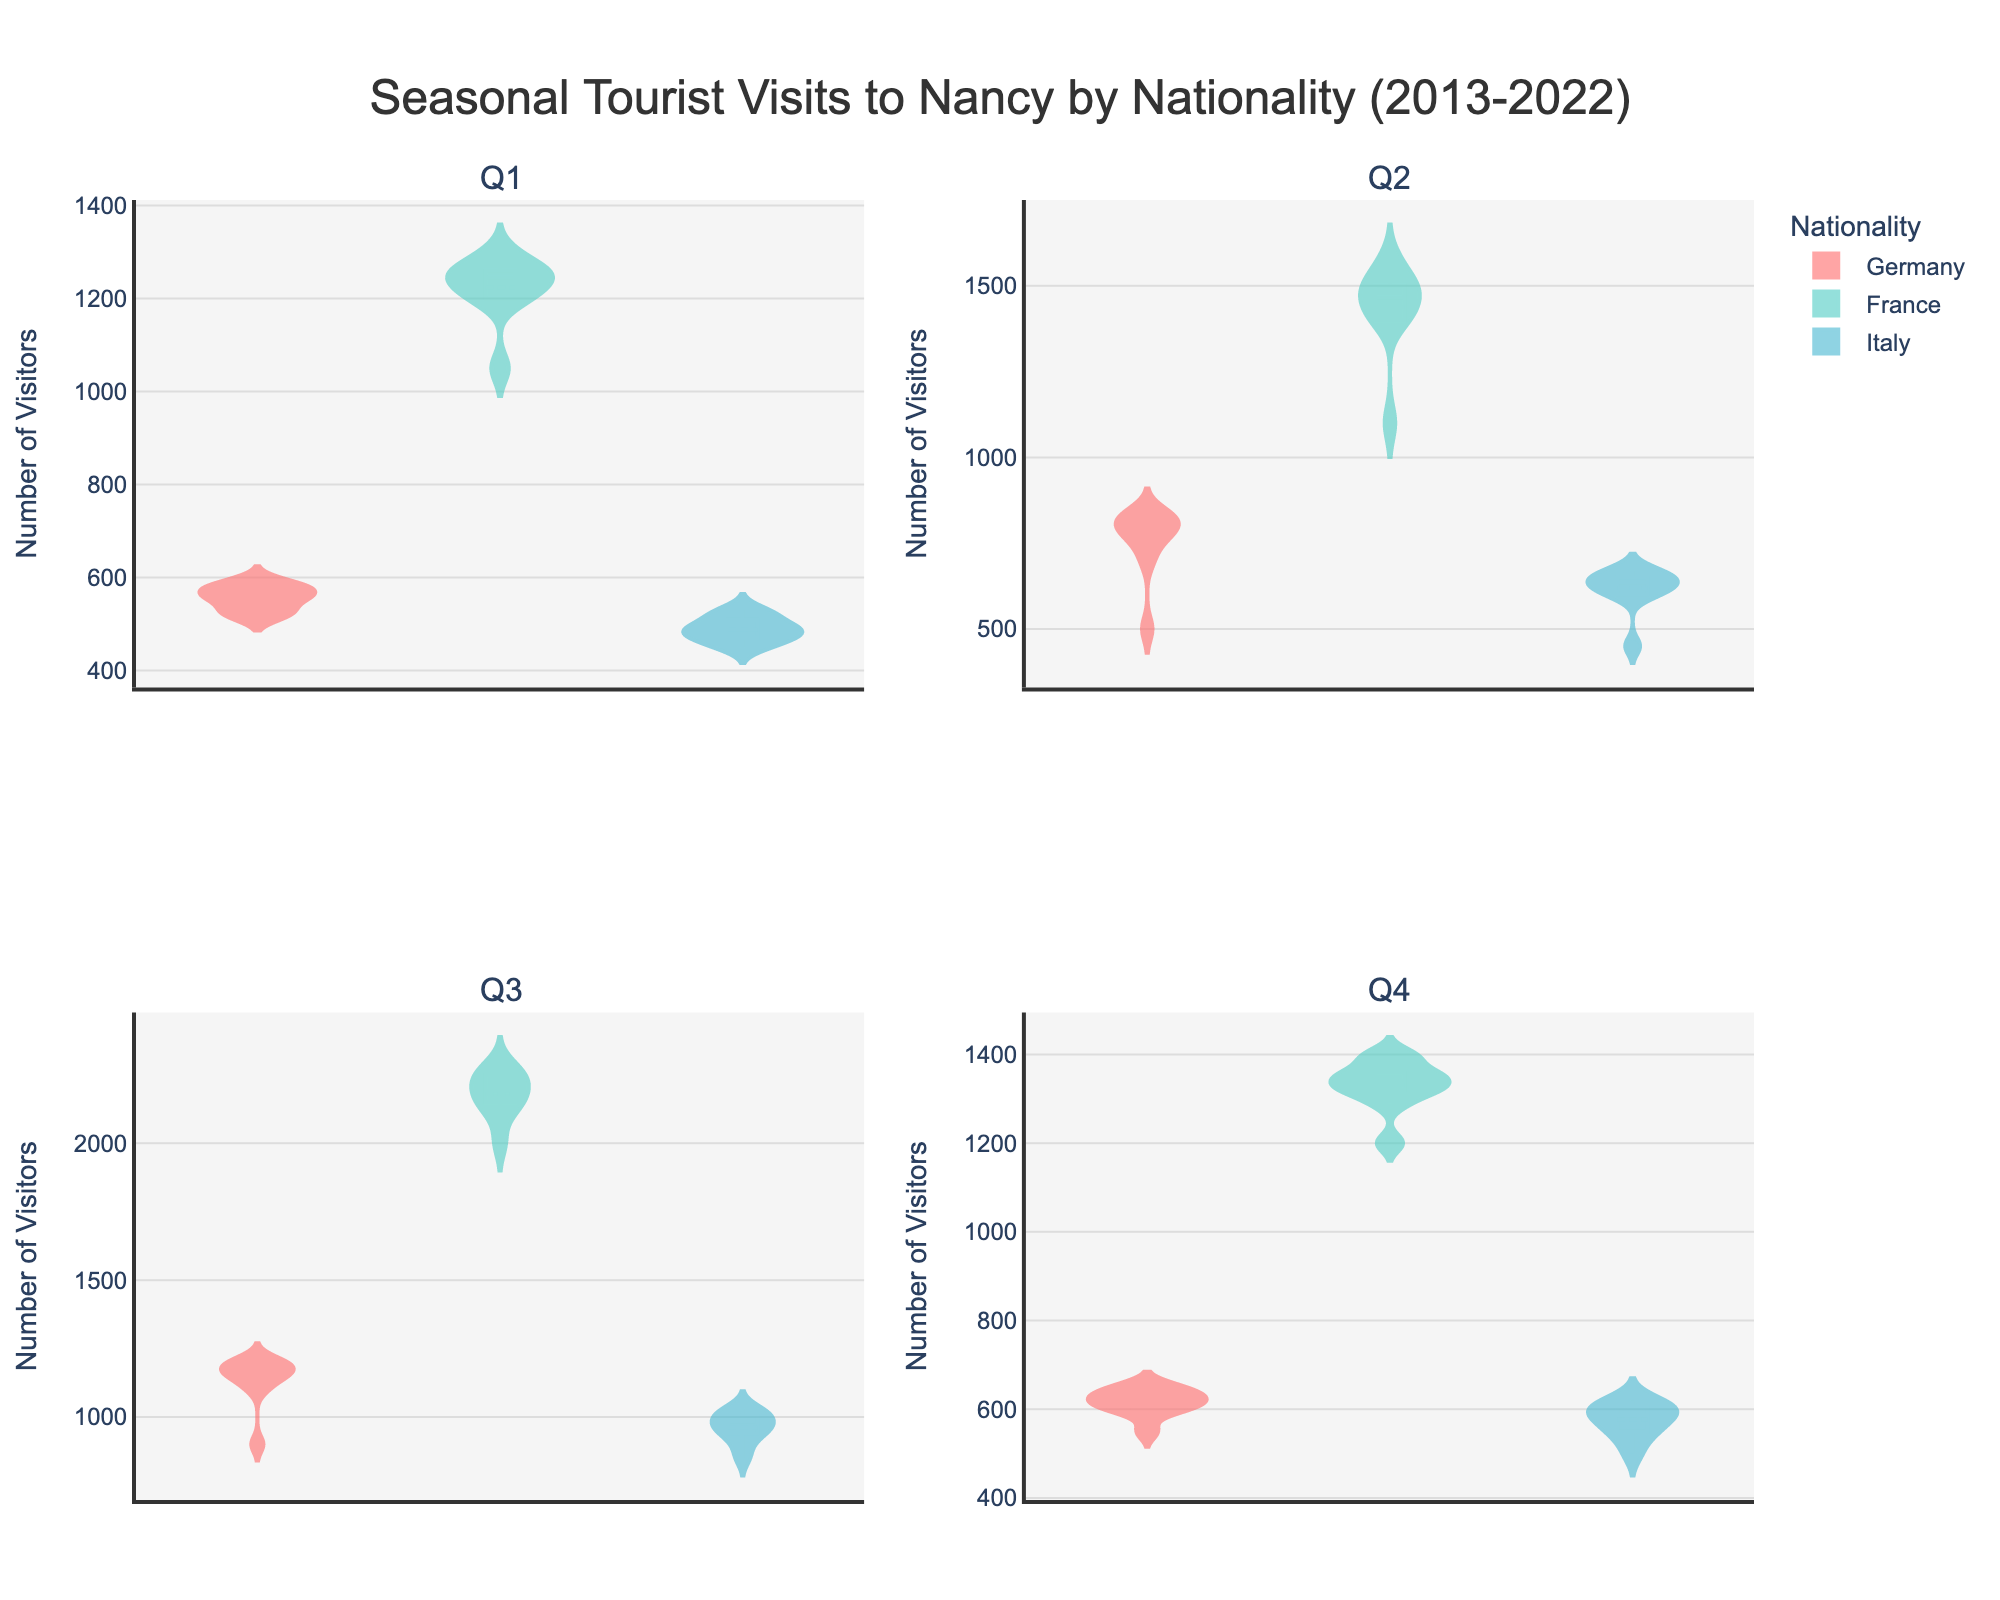What is the title of the figure? The title of the figure is prominently displayed at the top and provides an overview of the content being presented.
Answer: Seasonal Tourist Visits to Nancy by Nationality (2013-2022) How many subplots are there in the figure? There are four sections in the figure, each representing data for a different seasonal quarter. These sections are visually distinct and arranged in a 2x2 grid.
Answer: Four Which nationality tends to have the highest number of visitors in Q3? Observing the violin plots in the Q3 subplot, the plots show the distribution and mean number of visitors. The plot with the blue color, representing France, consistently has the highest values.
Answer: France What is the average number of visitors from Germany in Q1? To find the average, sum the number of visitors from Germany in Q1 for each year and then divide by the number of years (10 years). The sum is 550 + 520 + 560 + 530 + 570 + 580 + 590 + 560 + 520 + 580 = 5560. Dividing by 10 gives the average.
Answer: 556 Between Q2 and Q4, which quarter sees a higher number of visitors from Italy? Comparing the height and spread of the violin plots for Italy in Q2 and Q4, it is noticeable that Q2 generally has higher visitor numbers than Q4.
Answer: Q2 Which nationality shows the least variation in the number of visitors across all quarters? By comparing the width and spread of the violin plots for each nationality, it is clear that Germany shows the least variation, as its plots are narrower and more consistent in height across all quarters.
Answer: Germany In which quarter does the number of visitors from France peak? The plots for France show a significant increase in Q3 compared to other quarters, highlighted by taller plots in Q3.
Answer: Q3 Does the number of visitors from Italy in Q3 consistently increase over the years? Examining the individual points and overall distribution trend within the Q3 subplot for Italy, one can see that while there are fluctuations, there is no clear, consistent upward trend over the years.
Answer: No 